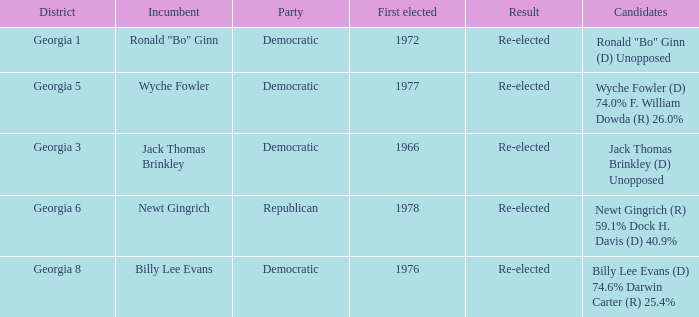How many candidates were first elected in 1972? 1.0. 